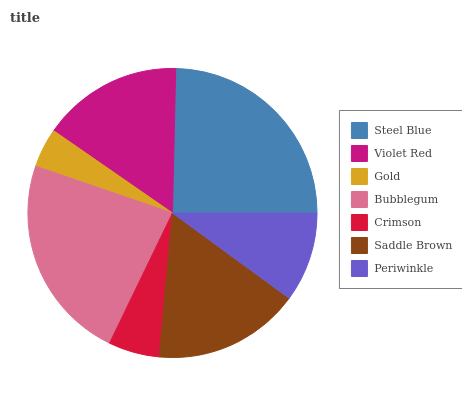Is Gold the minimum?
Answer yes or no. Yes. Is Steel Blue the maximum?
Answer yes or no. Yes. Is Violet Red the minimum?
Answer yes or no. No. Is Violet Red the maximum?
Answer yes or no. No. Is Steel Blue greater than Violet Red?
Answer yes or no. Yes. Is Violet Red less than Steel Blue?
Answer yes or no. Yes. Is Violet Red greater than Steel Blue?
Answer yes or no. No. Is Steel Blue less than Violet Red?
Answer yes or no. No. Is Violet Red the high median?
Answer yes or no. Yes. Is Violet Red the low median?
Answer yes or no. Yes. Is Saddle Brown the high median?
Answer yes or no. No. Is Steel Blue the low median?
Answer yes or no. No. 